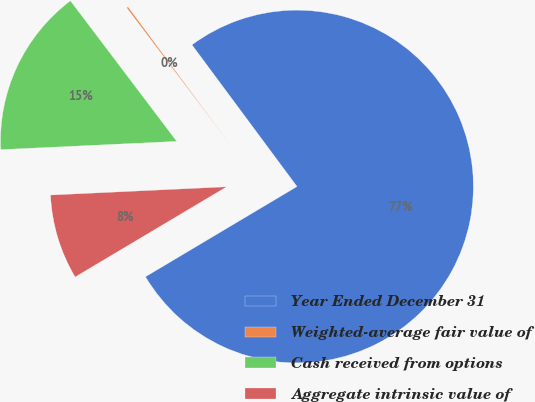Convert chart to OTSL. <chart><loc_0><loc_0><loc_500><loc_500><pie_chart><fcel>Year Ended December 31<fcel>Weighted-average fair value of<fcel>Cash received from options<fcel>Aggregate intrinsic value of<nl><fcel>76.6%<fcel>0.15%<fcel>15.44%<fcel>7.8%<nl></chart> 